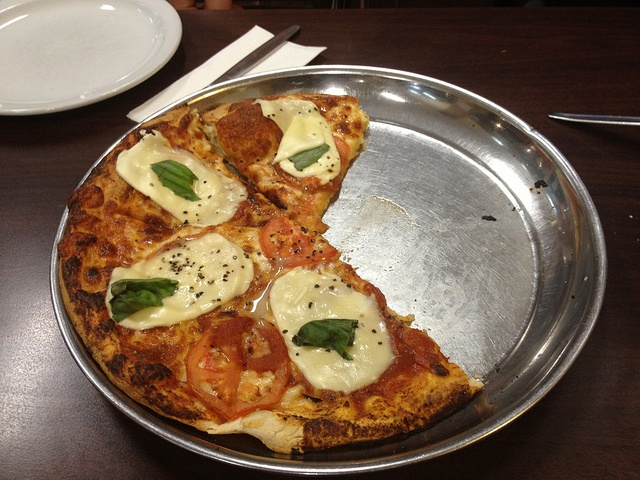Describe the objects in this image and their specific colors. I can see dining table in black, darkgray, maroon, brown, and tan tones, pizza in tan, brown, maroon, and khaki tones, knife in tan, maroon, gray, and ivory tones, and knife in tan, black, gray, darkgray, and lightgray tones in this image. 